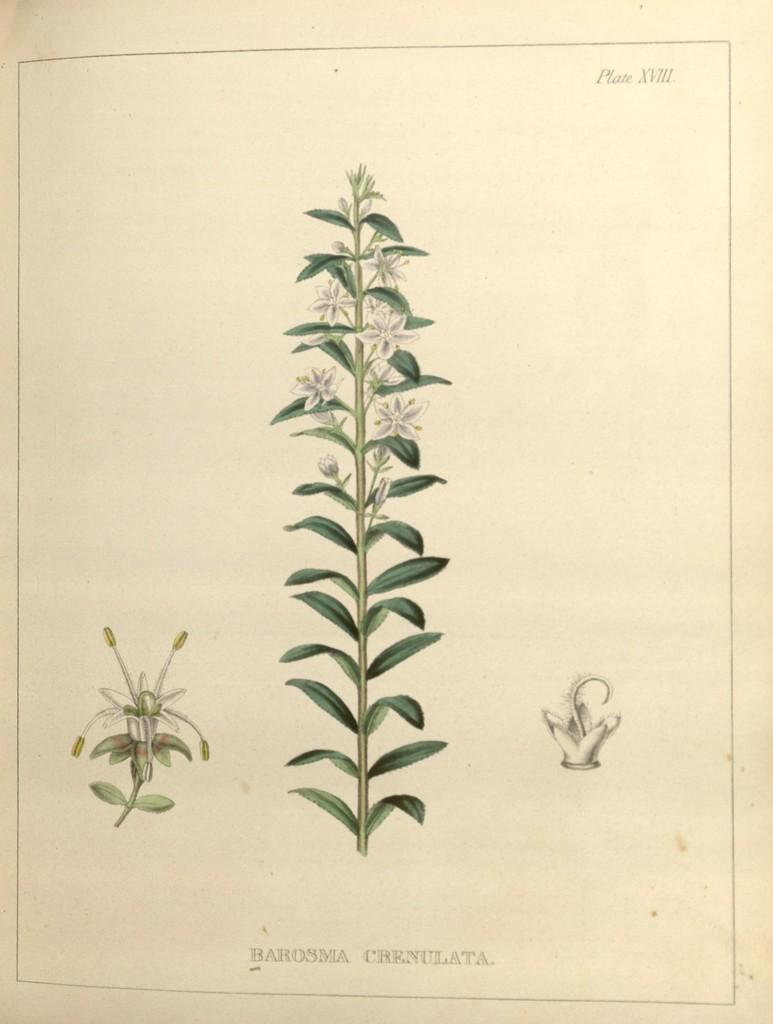What is the main subject of the paper in the image? The paper contains pictures of plants. Are there any other elements visible on the paper? Yes, there are words written on the paper and lines visible on it. What else can be seen in the image besides the paper? There are flowers visible in the image. How does the paper express regret in the image? The paper does not express regret in the image; it contains pictures of plants and words written on it. Can you describe the distribution of the flowers in the image? There is no specific distribution of the flowers mentioned in the facts; they are simply visible in the image. 